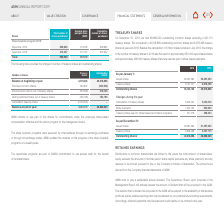According to Asm International Nv's financial document, What was the reason for the change in the number of treasury shares in 2019? the result of approximately 950,000 repurchased shares and approximately 498,000 treasury shares that were used as part of share based payments. The document states: "in the number of treasury shares in 2019 was the result of approximately 950,000 repurchased shares and approximately 498,000 treasury shares that wer..." Also, What is the number of outstanding common shares on December 31, 2019? According to the financial document, 48,866,220. The relevant text states: "Outstanding shares 49,318,898 48,866,220..." Also, What is the Cancellation of treasury shares for 2019? According to the financial document, 5,000,000. The relevant text states: "Cancellation of treasury shares 6,000,000 5,000,000..." Also, can you calculate: What is the  Outstanding shares expressed as a ratio of  Issued shares for december 2019? Based on the calculation:  48,866,220/51,297,394, the result is 0.95. This is based on the information: "Outstanding shares 49,318,898 48,866,220 Issued shares 56,297,394 51,297,394..." The key data points involved are: 48,866,220, 51,297,394. Also, can you calculate: What is the percentage change in  Share buybacks from during the year 2018 to during the year 2019? To answer this question, I need to perform calculations using the financial data. The calculation is:  (950,902-7,242,734)/ 7,242,734, which equals -86.87 (percentage). This is based on the information: "Share buybacks 7,242,734 950,902 Share buybacks 7,242,734 950,902..." The key data points involved are: 7,242,734, 950,902. Also, can you calculate: What is the percentage change in outstanding shares  As per December 31 from 2018 to 2019? To answer this question, I need to perform calculations using the financial data. The calculation is: (48,866,220- 49,318,898)/ 49,318,898, which equals -0.92 (percentage). This is based on the information: "Outstanding shares 49,318,898 48,866,220 Outstanding shares 49,318,898 48,866,220..." The key data points involved are: 48,866,220, 49,318,898. 